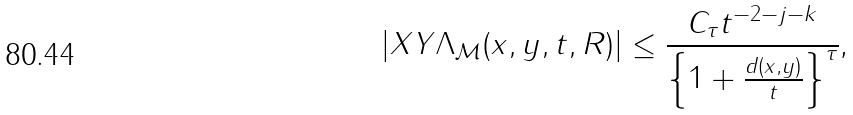Convert formula to latex. <formula><loc_0><loc_0><loc_500><loc_500>\left | X Y \Lambda _ { \mathcal { M } } ( x , y , t , R ) \right | \leq \frac { C _ { \tau } t ^ { - 2 - j - k } } { \left \{ 1 + \frac { d ( x , y ) } { t } \right \} ^ { \tau } } \text {,}</formula> 